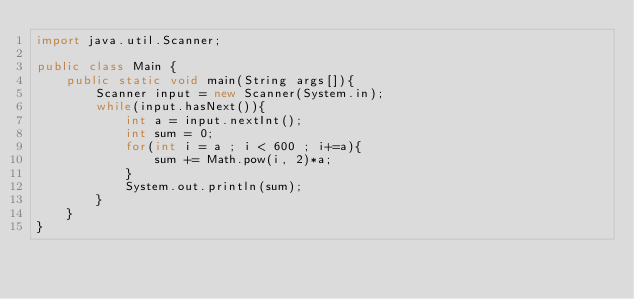Convert code to text. <code><loc_0><loc_0><loc_500><loc_500><_Java_>import java.util.Scanner;

public class Main {
    public static void main(String args[]){
        Scanner input = new Scanner(System.in);
        while(input.hasNext()){
        	int a = input.nextInt();
        	int sum = 0;
        	for(int i = a ; i < 600 ; i+=a){
        		sum += Math.pow(i, 2)*a;
        	}
        	System.out.println(sum);
        }
    }    
}</code> 